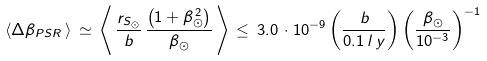<formula> <loc_0><loc_0><loc_500><loc_500>\langle \Delta \beta _ { P S R } \, \rangle \, \simeq \, \left \langle \, \frac { r _ { S _ { \odot } } } { b } \, \frac { \left ( 1 + \beta ^ { \, 2 } _ { \odot } \right ) } { \beta _ { \odot } } \, \right \rangle \, \leq \, 3 . 0 \, \cdot 1 0 ^ { - 9 } \left ( \frac { b } { 0 . 1 \, l \, y } \right ) \left ( \frac { \beta _ { \odot } } { 1 0 ^ { - 3 } } \right ) ^ { - 1 }</formula> 